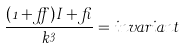Convert formula to latex. <formula><loc_0><loc_0><loc_500><loc_500>\frac { ( 1 + \alpha ) I + \beta } { k ^ { 3 } } = i n v a r i a n t</formula> 